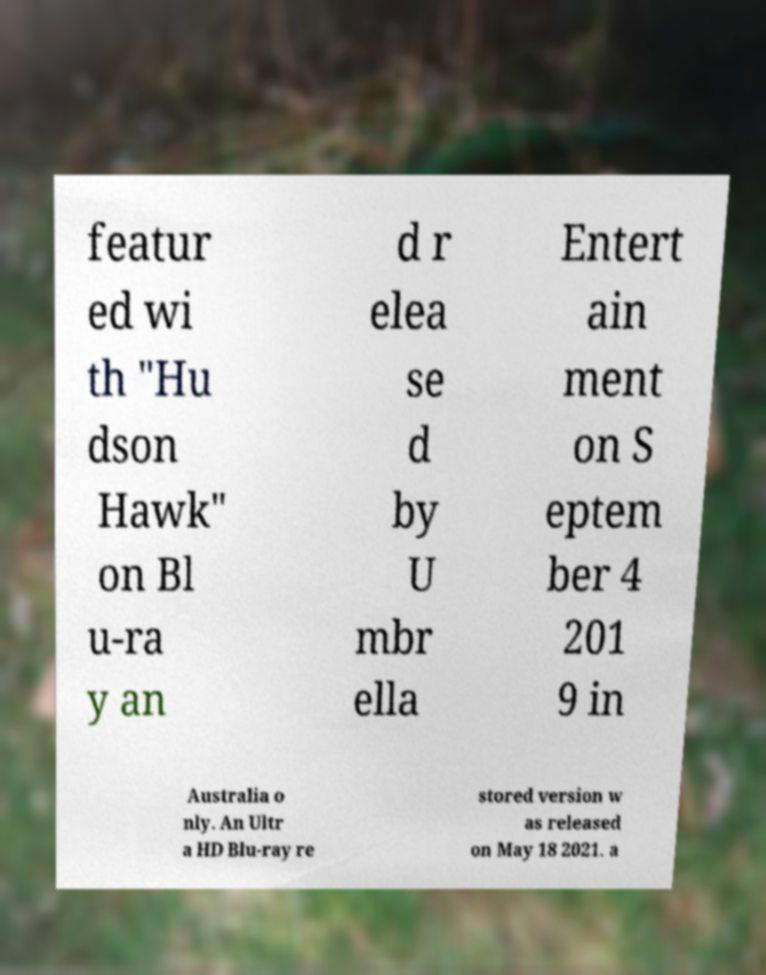Please read and relay the text visible in this image. What does it say? featur ed wi th "Hu dson Hawk" on Bl u-ra y an d r elea se d by U mbr ella Entert ain ment on S eptem ber 4 201 9 in Australia o nly. An Ultr a HD Blu-ray re stored version w as released on May 18 2021. a 